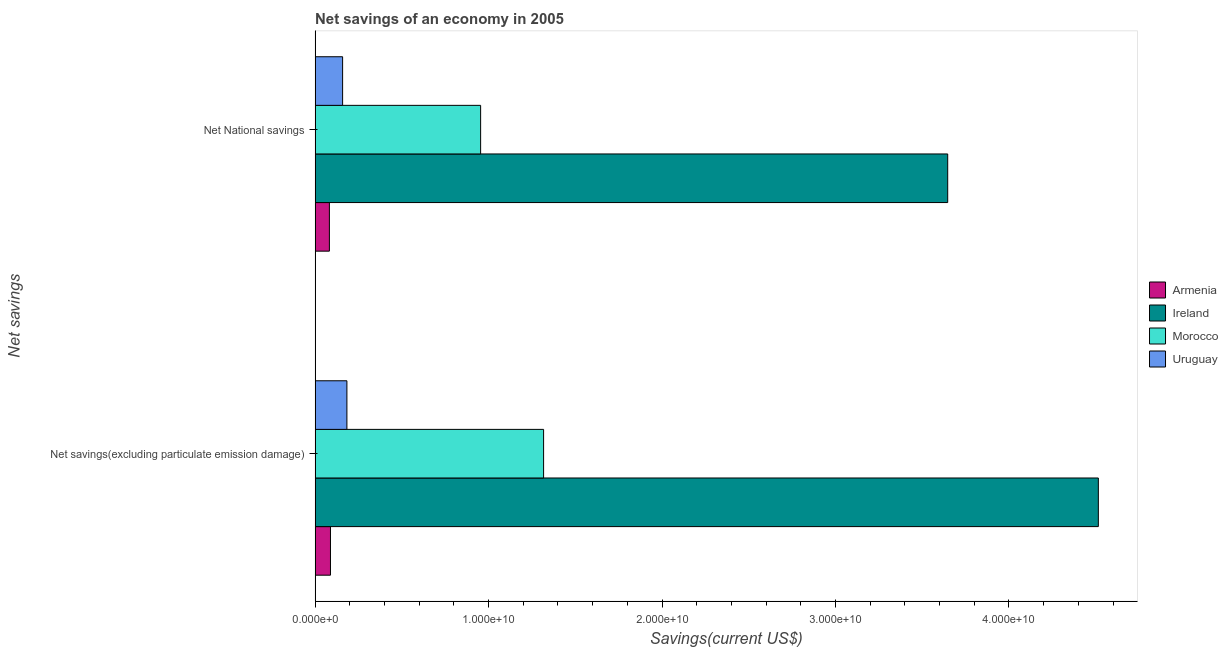How many different coloured bars are there?
Your answer should be compact. 4. How many bars are there on the 1st tick from the bottom?
Your answer should be very brief. 4. What is the label of the 2nd group of bars from the top?
Offer a very short reply. Net savings(excluding particulate emission damage). What is the net national savings in Morocco?
Ensure brevity in your answer.  9.54e+09. Across all countries, what is the maximum net savings(excluding particulate emission damage)?
Give a very brief answer. 4.52e+1. Across all countries, what is the minimum net savings(excluding particulate emission damage)?
Provide a succinct answer. 8.86e+08. In which country was the net national savings maximum?
Your answer should be very brief. Ireland. In which country was the net national savings minimum?
Provide a succinct answer. Armenia. What is the total net savings(excluding particulate emission damage) in the graph?
Ensure brevity in your answer.  6.10e+1. What is the difference between the net national savings in Uruguay and that in Morocco?
Your answer should be compact. -7.96e+09. What is the difference between the net national savings in Uruguay and the net savings(excluding particulate emission damage) in Armenia?
Give a very brief answer. 7.00e+08. What is the average net national savings per country?
Provide a succinct answer. 1.21e+1. What is the difference between the net savings(excluding particulate emission damage) and net national savings in Morocco?
Provide a succinct answer. 3.63e+09. What is the ratio of the net national savings in Armenia to that in Uruguay?
Offer a very short reply. 0.52. Is the net savings(excluding particulate emission damage) in Armenia less than that in Uruguay?
Your answer should be very brief. Yes. What does the 2nd bar from the top in Net savings(excluding particulate emission damage) represents?
Keep it short and to the point. Morocco. What does the 1st bar from the bottom in Net savings(excluding particulate emission damage) represents?
Make the answer very short. Armenia. How many bars are there?
Your answer should be compact. 8. Are all the bars in the graph horizontal?
Make the answer very short. Yes. How many countries are there in the graph?
Keep it short and to the point. 4. Are the values on the major ticks of X-axis written in scientific E-notation?
Provide a succinct answer. Yes. Does the graph contain any zero values?
Make the answer very short. No. How are the legend labels stacked?
Your response must be concise. Vertical. What is the title of the graph?
Provide a succinct answer. Net savings of an economy in 2005. Does "United Kingdom" appear as one of the legend labels in the graph?
Provide a succinct answer. No. What is the label or title of the X-axis?
Give a very brief answer. Savings(current US$). What is the label or title of the Y-axis?
Give a very brief answer. Net savings. What is the Savings(current US$) of Armenia in Net savings(excluding particulate emission damage)?
Provide a short and direct response. 8.86e+08. What is the Savings(current US$) in Ireland in Net savings(excluding particulate emission damage)?
Provide a short and direct response. 4.52e+1. What is the Savings(current US$) in Morocco in Net savings(excluding particulate emission damage)?
Your response must be concise. 1.32e+1. What is the Savings(current US$) of Uruguay in Net savings(excluding particulate emission damage)?
Provide a succinct answer. 1.83e+09. What is the Savings(current US$) of Armenia in Net National savings?
Ensure brevity in your answer.  8.24e+08. What is the Savings(current US$) of Ireland in Net National savings?
Offer a terse response. 3.65e+1. What is the Savings(current US$) of Morocco in Net National savings?
Offer a terse response. 9.54e+09. What is the Savings(current US$) of Uruguay in Net National savings?
Your answer should be very brief. 1.59e+09. Across all Net savings, what is the maximum Savings(current US$) in Armenia?
Ensure brevity in your answer.  8.86e+08. Across all Net savings, what is the maximum Savings(current US$) in Ireland?
Make the answer very short. 4.52e+1. Across all Net savings, what is the maximum Savings(current US$) in Morocco?
Give a very brief answer. 1.32e+1. Across all Net savings, what is the maximum Savings(current US$) in Uruguay?
Provide a succinct answer. 1.83e+09. Across all Net savings, what is the minimum Savings(current US$) of Armenia?
Offer a very short reply. 8.24e+08. Across all Net savings, what is the minimum Savings(current US$) in Ireland?
Ensure brevity in your answer.  3.65e+1. Across all Net savings, what is the minimum Savings(current US$) of Morocco?
Offer a very short reply. 9.54e+09. Across all Net savings, what is the minimum Savings(current US$) of Uruguay?
Keep it short and to the point. 1.59e+09. What is the total Savings(current US$) of Armenia in the graph?
Keep it short and to the point. 1.71e+09. What is the total Savings(current US$) in Ireland in the graph?
Your answer should be compact. 8.16e+1. What is the total Savings(current US$) of Morocco in the graph?
Provide a succinct answer. 2.27e+1. What is the total Savings(current US$) of Uruguay in the graph?
Keep it short and to the point. 3.42e+09. What is the difference between the Savings(current US$) of Armenia in Net savings(excluding particulate emission damage) and that in Net National savings?
Your answer should be very brief. 6.23e+07. What is the difference between the Savings(current US$) in Ireland in Net savings(excluding particulate emission damage) and that in Net National savings?
Provide a succinct answer. 8.68e+09. What is the difference between the Savings(current US$) of Morocco in Net savings(excluding particulate emission damage) and that in Net National savings?
Make the answer very short. 3.63e+09. What is the difference between the Savings(current US$) in Uruguay in Net savings(excluding particulate emission damage) and that in Net National savings?
Your answer should be compact. 2.47e+08. What is the difference between the Savings(current US$) in Armenia in Net savings(excluding particulate emission damage) and the Savings(current US$) in Ireland in Net National savings?
Your answer should be very brief. -3.56e+1. What is the difference between the Savings(current US$) in Armenia in Net savings(excluding particulate emission damage) and the Savings(current US$) in Morocco in Net National savings?
Offer a very short reply. -8.66e+09. What is the difference between the Savings(current US$) of Armenia in Net savings(excluding particulate emission damage) and the Savings(current US$) of Uruguay in Net National savings?
Your response must be concise. -7.00e+08. What is the difference between the Savings(current US$) in Ireland in Net savings(excluding particulate emission damage) and the Savings(current US$) in Morocco in Net National savings?
Your answer should be compact. 3.56e+1. What is the difference between the Savings(current US$) of Ireland in Net savings(excluding particulate emission damage) and the Savings(current US$) of Uruguay in Net National savings?
Keep it short and to the point. 4.36e+1. What is the difference between the Savings(current US$) of Morocco in Net savings(excluding particulate emission damage) and the Savings(current US$) of Uruguay in Net National savings?
Offer a very short reply. 1.16e+1. What is the average Savings(current US$) in Armenia per Net savings?
Ensure brevity in your answer.  8.55e+08. What is the average Savings(current US$) in Ireland per Net savings?
Your answer should be very brief. 4.08e+1. What is the average Savings(current US$) in Morocco per Net savings?
Your response must be concise. 1.14e+1. What is the average Savings(current US$) of Uruguay per Net savings?
Ensure brevity in your answer.  1.71e+09. What is the difference between the Savings(current US$) of Armenia and Savings(current US$) of Ireland in Net savings(excluding particulate emission damage)?
Keep it short and to the point. -4.43e+1. What is the difference between the Savings(current US$) in Armenia and Savings(current US$) in Morocco in Net savings(excluding particulate emission damage)?
Make the answer very short. -1.23e+1. What is the difference between the Savings(current US$) in Armenia and Savings(current US$) in Uruguay in Net savings(excluding particulate emission damage)?
Provide a short and direct response. -9.47e+08. What is the difference between the Savings(current US$) of Ireland and Savings(current US$) of Morocco in Net savings(excluding particulate emission damage)?
Provide a short and direct response. 3.20e+1. What is the difference between the Savings(current US$) of Ireland and Savings(current US$) of Uruguay in Net savings(excluding particulate emission damage)?
Offer a terse response. 4.33e+1. What is the difference between the Savings(current US$) in Morocco and Savings(current US$) in Uruguay in Net savings(excluding particulate emission damage)?
Offer a terse response. 1.13e+1. What is the difference between the Savings(current US$) in Armenia and Savings(current US$) in Ireland in Net National savings?
Offer a terse response. -3.56e+1. What is the difference between the Savings(current US$) in Armenia and Savings(current US$) in Morocco in Net National savings?
Provide a short and direct response. -8.72e+09. What is the difference between the Savings(current US$) of Armenia and Savings(current US$) of Uruguay in Net National savings?
Ensure brevity in your answer.  -7.62e+08. What is the difference between the Savings(current US$) of Ireland and Savings(current US$) of Morocco in Net National savings?
Provide a succinct answer. 2.69e+1. What is the difference between the Savings(current US$) in Ireland and Savings(current US$) in Uruguay in Net National savings?
Your response must be concise. 3.49e+1. What is the difference between the Savings(current US$) of Morocco and Savings(current US$) of Uruguay in Net National savings?
Your response must be concise. 7.96e+09. What is the ratio of the Savings(current US$) of Armenia in Net savings(excluding particulate emission damage) to that in Net National savings?
Offer a terse response. 1.08. What is the ratio of the Savings(current US$) in Ireland in Net savings(excluding particulate emission damage) to that in Net National savings?
Give a very brief answer. 1.24. What is the ratio of the Savings(current US$) in Morocco in Net savings(excluding particulate emission damage) to that in Net National savings?
Give a very brief answer. 1.38. What is the ratio of the Savings(current US$) of Uruguay in Net savings(excluding particulate emission damage) to that in Net National savings?
Ensure brevity in your answer.  1.16. What is the difference between the highest and the second highest Savings(current US$) in Armenia?
Provide a succinct answer. 6.23e+07. What is the difference between the highest and the second highest Savings(current US$) in Ireland?
Offer a very short reply. 8.68e+09. What is the difference between the highest and the second highest Savings(current US$) in Morocco?
Make the answer very short. 3.63e+09. What is the difference between the highest and the second highest Savings(current US$) of Uruguay?
Make the answer very short. 2.47e+08. What is the difference between the highest and the lowest Savings(current US$) of Armenia?
Your answer should be very brief. 6.23e+07. What is the difference between the highest and the lowest Savings(current US$) in Ireland?
Your response must be concise. 8.68e+09. What is the difference between the highest and the lowest Savings(current US$) of Morocco?
Offer a very short reply. 3.63e+09. What is the difference between the highest and the lowest Savings(current US$) of Uruguay?
Offer a very short reply. 2.47e+08. 